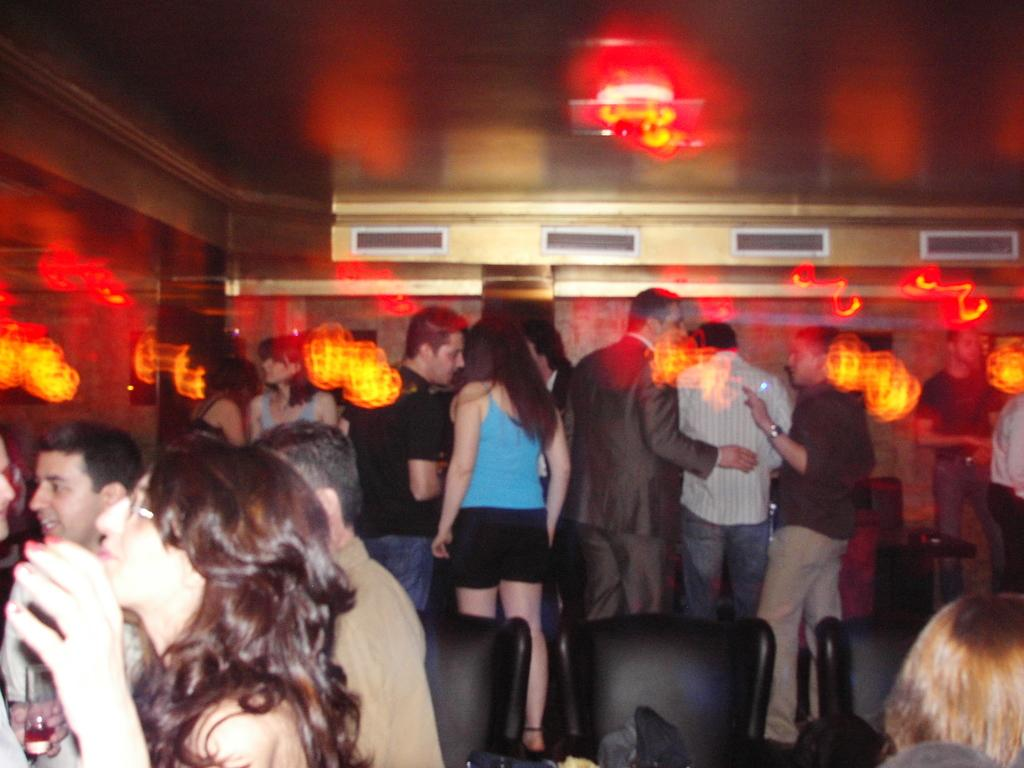What type of furniture is present in the image? There are chairs in the image. Are there any people in the image? Yes, there are people in the image. Can you describe any other objects in the image besides the chairs and people? Unfortunately, the provided facts do not specify any other objects in the image. How many balloons are being held by the people in the image? There is no mention of balloons in the image, so it is impossible to determine how many, if any, are being held by the people. 